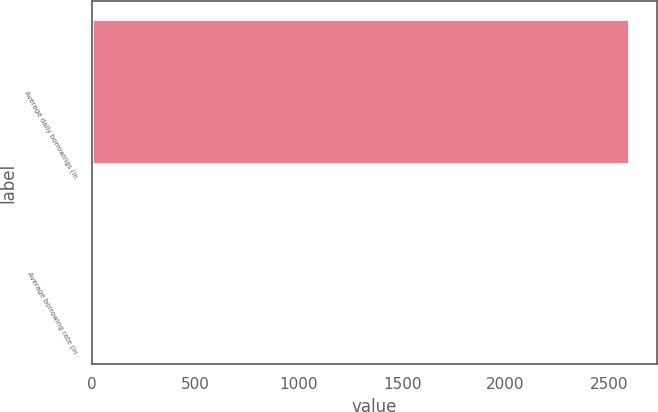<chart> <loc_0><loc_0><loc_500><loc_500><bar_chart><fcel>Average daily borrowings (in<fcel>Average borrowing rate (in<nl><fcel>2602<fcel>7<nl></chart> 